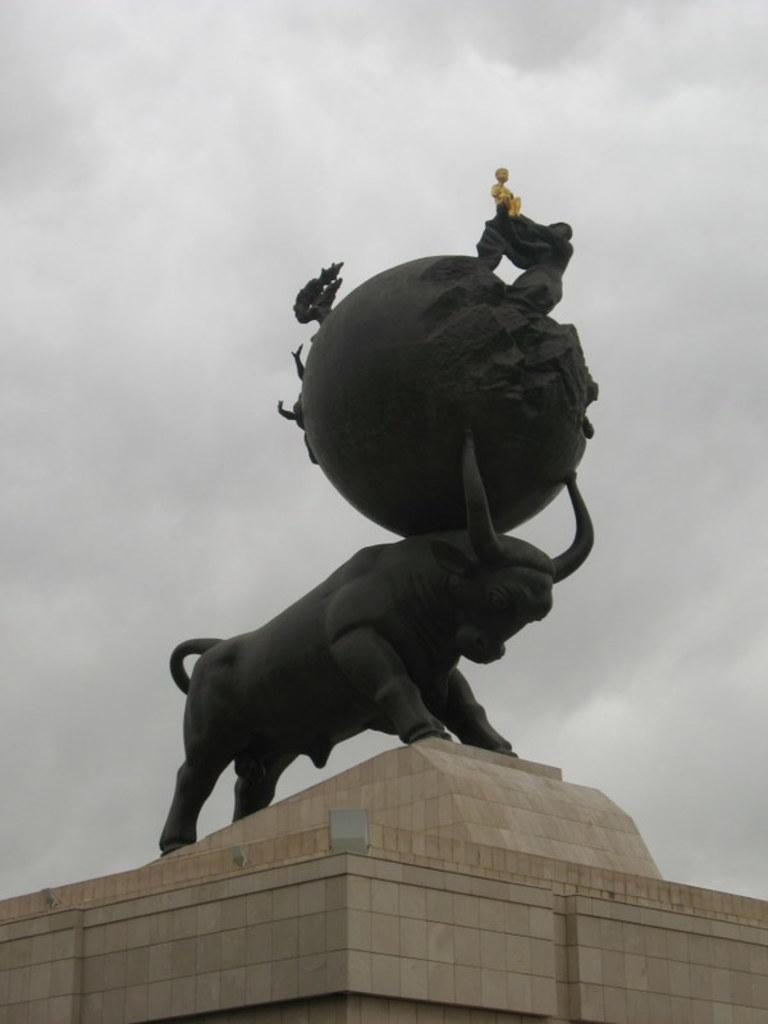What is the main subject in the center of the image? There is a statue in the center of the image. What can be seen in the background of the image? Sky and clouds are visible in the background of the image. What type of relation does the army have with the statue in the image? There is no army present in the image, so it is not possible to determine any relation between the army and the statue. 